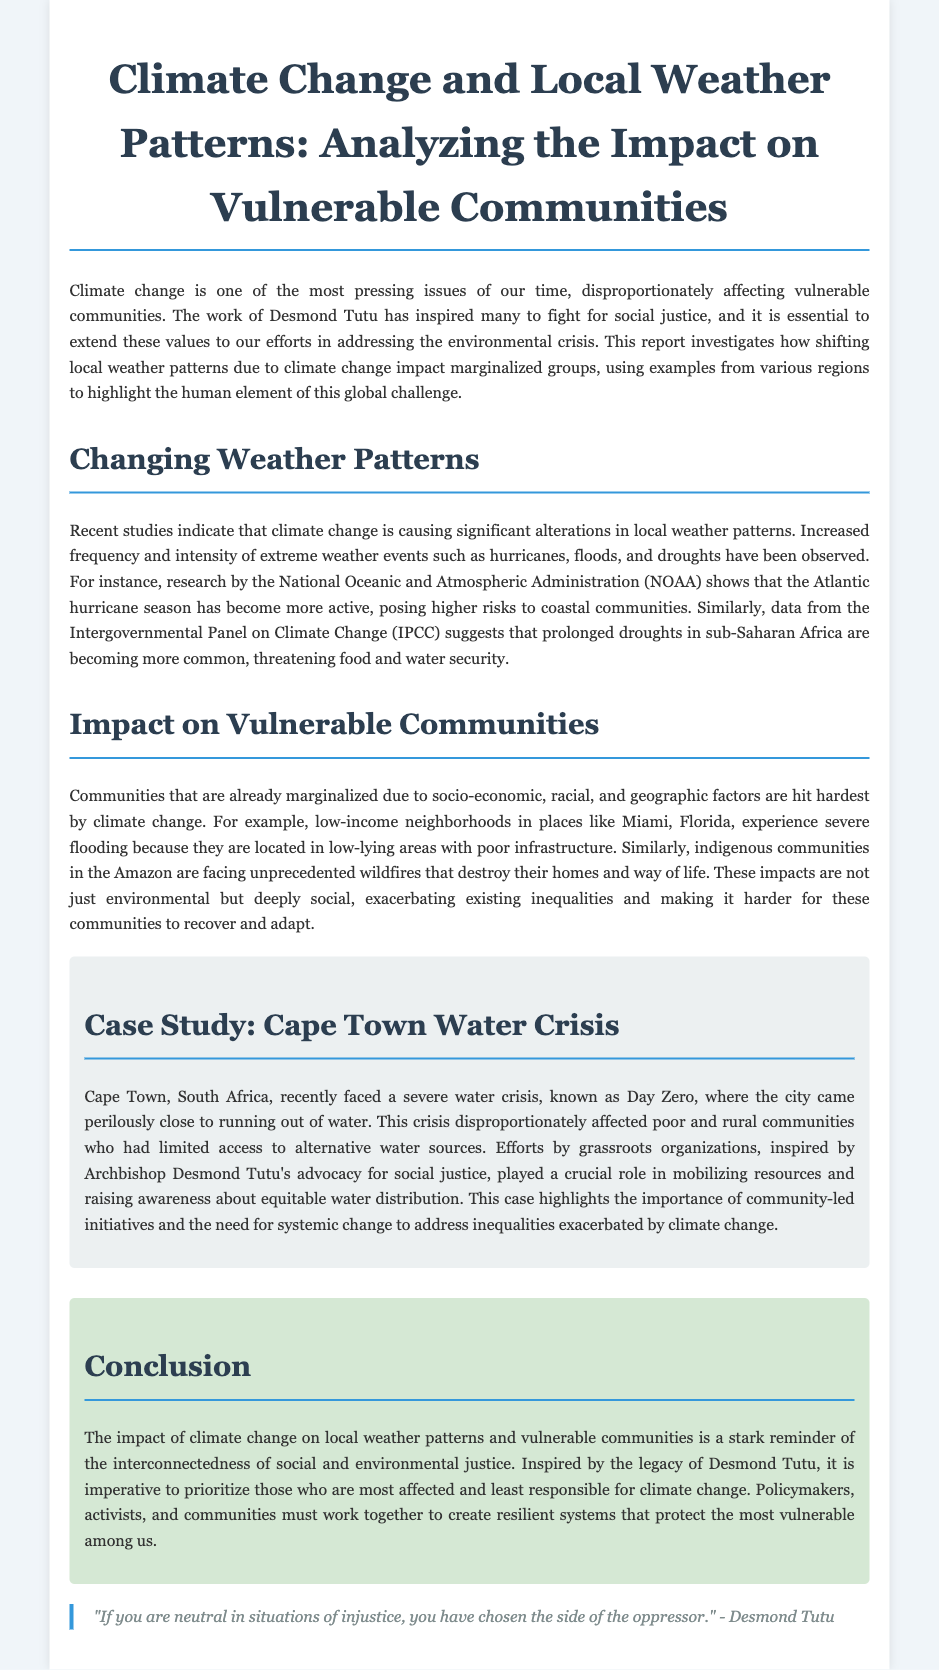What is the title of the report? The title is explicitly stated at the beginning of the document.
Answer: Climate Change and Local Weather Patterns: Analyzing the Impact on Vulnerable Communities What is one extreme weather event mentioned in the report? The report lists specific extreme weather events as part of the discussion on changing weather patterns.
Answer: hurricanes Which organization provided research on the Atlantic hurricane season? The report references a specific organization related to research findings mentioned in the text.
Answer: National Oceanic and Atmospheric Administration (NOAA) What crisis did Cape Town recently face? The document describes a specific event that caused significant concern for the citizens of Cape Town.
Answer: water crisis Who is cited in the quote at the end of the document? The document includes a thought-provoking quote relevant to the themes discussed.
Answer: Desmond Tutu What do low-income neighborhoods in Miami experience due to flooding? The report discusses the conditions faced by particular communities affected by climate change.
Answer: severe flooding Which communities are facing wildfires according to the report? The document specifies groups affected by environmental issues raised in the text.
Answer: indigenous communities in the Amazon What is essential to mobilize resources according to the Cape Town case study? The report highlights what played a crucial role during the crisis mentioned.
Answer: grassroots organizations What is the main call to action in the conclusion? The conclusion states what must be prioritized in addressing the crisis of climate change.
Answer: protect the most vulnerable among us 